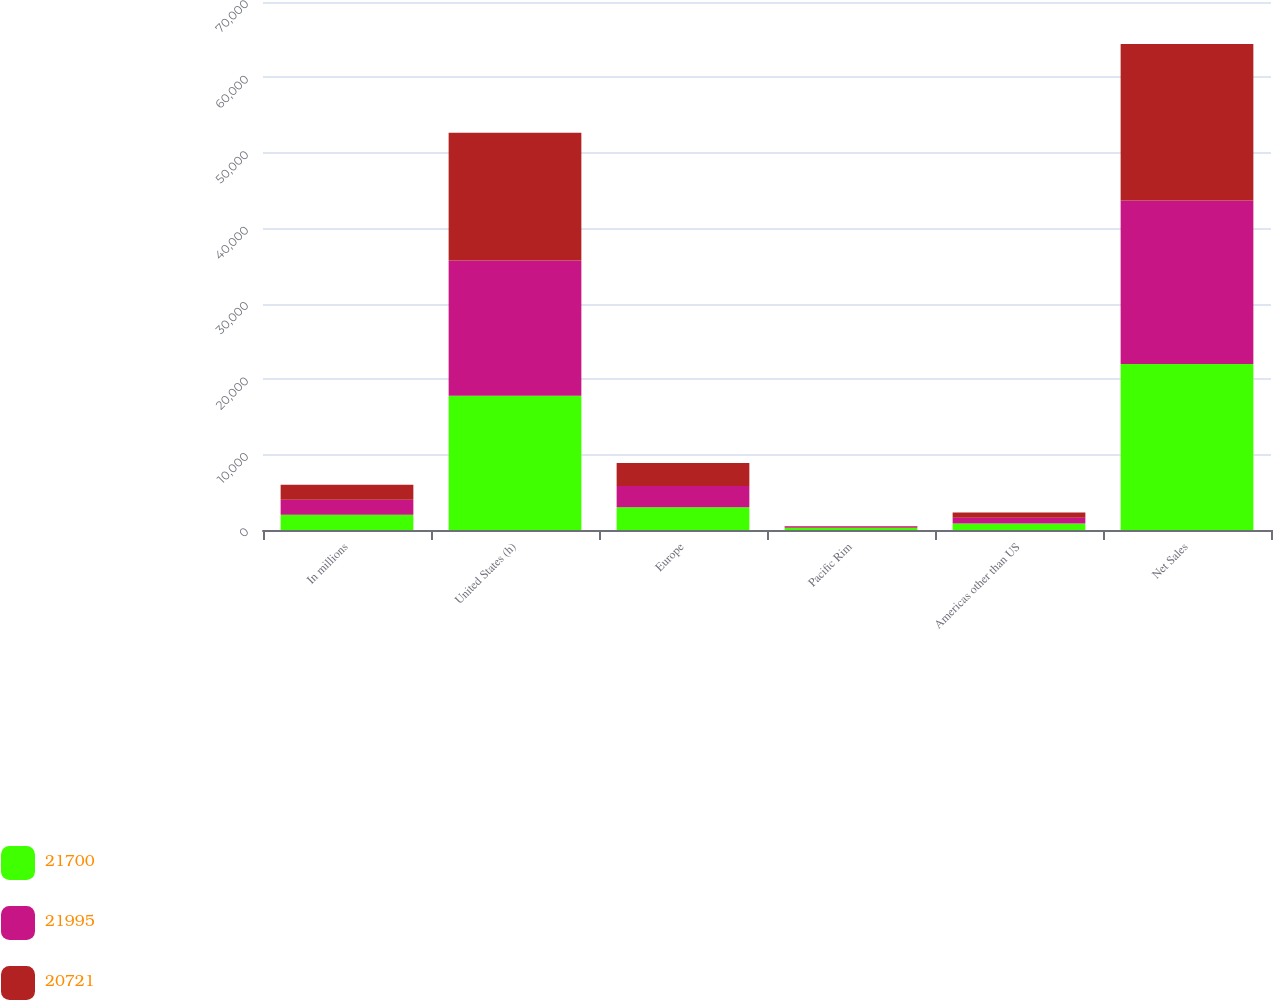Convert chart. <chart><loc_0><loc_0><loc_500><loc_500><stacked_bar_chart><ecel><fcel>In millions<fcel>United States (h)<fcel>Europe<fcel>Pacific Rim<fcel>Americas other than US<fcel>Net Sales<nl><fcel>21700<fcel>2006<fcel>17811<fcel>3030<fcel>308<fcel>846<fcel>21995<nl><fcel>21995<fcel>2005<fcel>17934<fcel>2809<fcel>169<fcel>788<fcel>21700<nl><fcel>20721<fcel>2004<fcel>16915<fcel>3056<fcel>58<fcel>692<fcel>20721<nl></chart> 